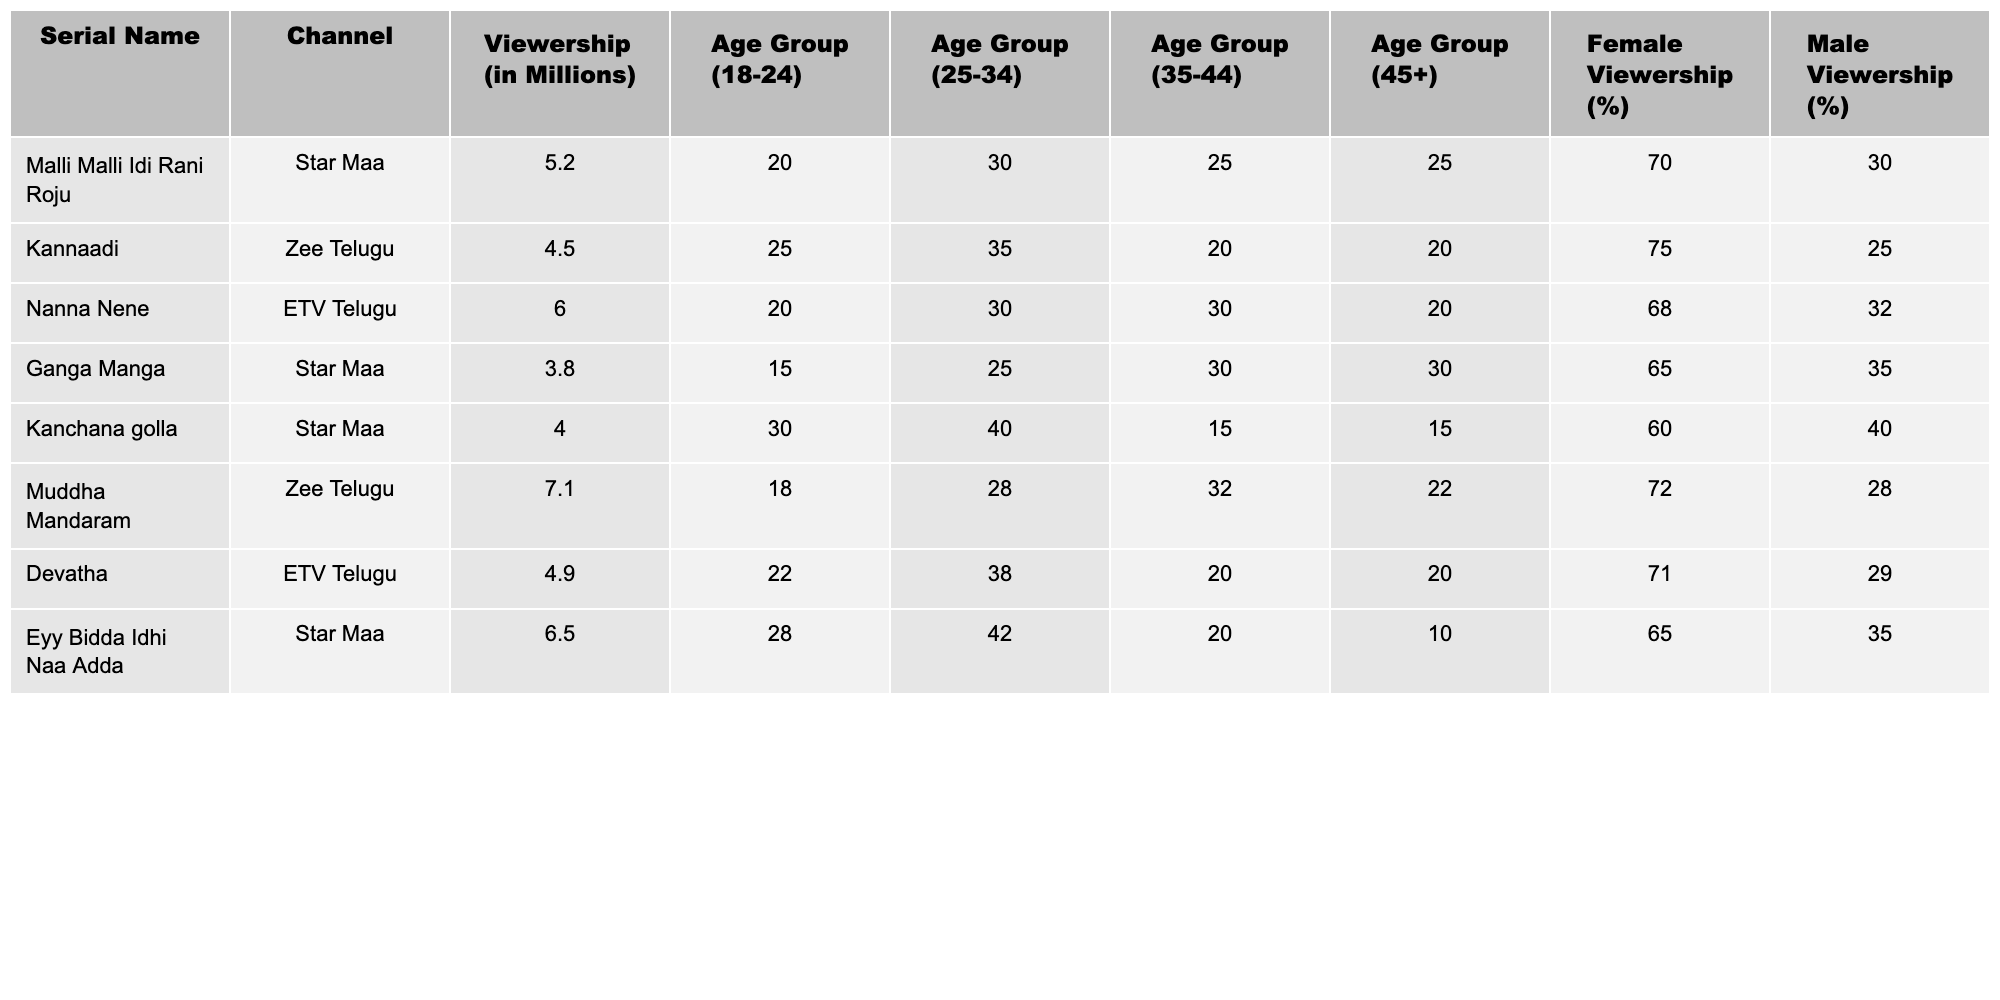What is the viewership of the serial "Muddha Mandaram"? The table shows that the viewership for "Muddha Mandaram" is 7.1 million.
Answer: 7.1 million Which serial has the highest female viewership percentage? By comparing the percentages in the Female Viewership column, "Kannaadi" has the highest female viewership at 75%.
Answer: 75% What is the average viewership of the serials aired on Star Maa? The viewership numbers for Star Maa are 5.2, 3.8, 4.0, and 6.5 million. Their sum is 19.5 million, and dividing by 4 gives an average of 4.875 million.
Answer: 4.875 million Is the male viewership percentage for "Eyy Bidda Idhi Naa Adda" less than 40%? The male viewership percentage for "Eyy Bidda Idhi Naa Adda" is 35%, which is less than 40%.
Answer: Yes What is the sum of the viewership of the serials from ETV Telugu? The viewership of ETV Telugu serials is 6.0 and 4.9 million. Adding them gives 10.9 million.
Answer: 10.9 million Which age group has the highest viewership for the serial "Kanchana golla"? In the "Kanchana golla" row, the data reveals that the age group 25-34 has the highest viewership at 40%.
Answer: 25-34 How many serials have viewership greater than 5 million? The serials with viewership greater than 5 million are "Nanna Nene," "Muddha Mandaram," and "Eyy Bidda Idhi Naa Adda." This totals 3 serials.
Answer: 3 What is the difference in female viewership percentage between "Devatha" and "Ganga Manga"? "Devatha" has 71% female viewership and "Ganga Manga" has 65%. The difference is 71 - 65 = 6%.
Answer: 6% Which serial has the lowest viewership? The table indicates that "Ganga Manga" has the lowest viewership at 3.8 million.
Answer: 3.8 million If you combine the viewership of "Malli Malli Idi Rani Roju" and "Muddha Mandaram," what will be the total? Adding the viewership of both serials gives 5.2 million + 7.1 million = 12.3 million.
Answer: 12.3 million 